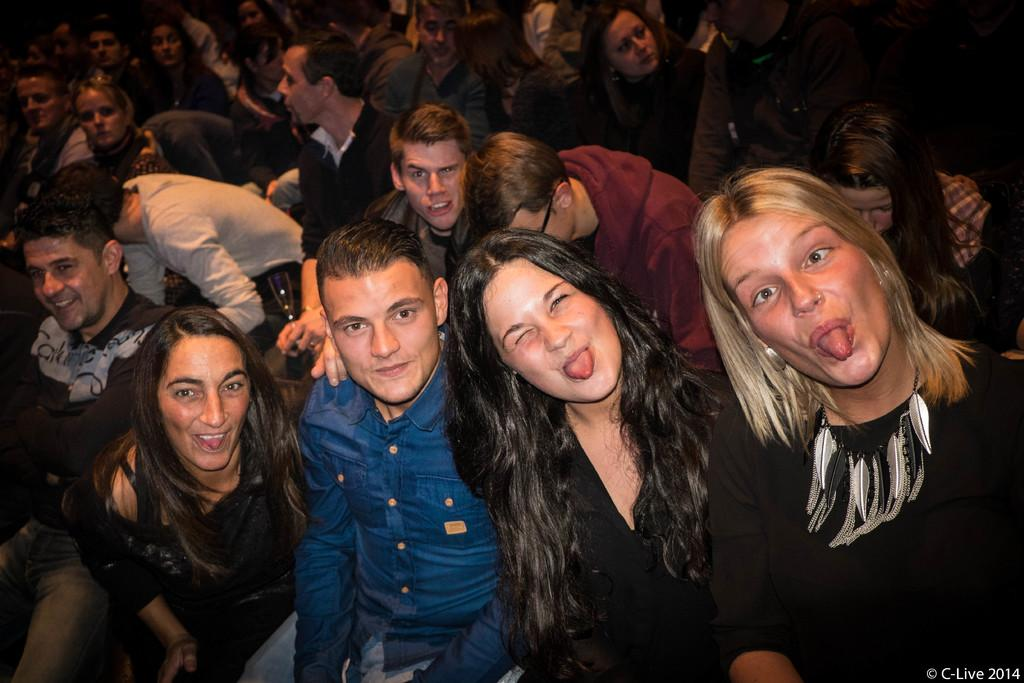What are the people in the image doing? The people in the image are sitting. Can you describe the group of people in the front of the image? There are four persons posing for a camera in the front of the image. What color shirt is one of the persons wearing? One person is wearing a blue color shirt. What color dress are three of the persons wearing? Three persons are wearing black color dress. Can you tell me how many soap bars are on the table in the image? There is no table or soap bars present in the image. What type of yam is being cooked in the background of the image? There is no yam or cooking activity depicted in the image. 